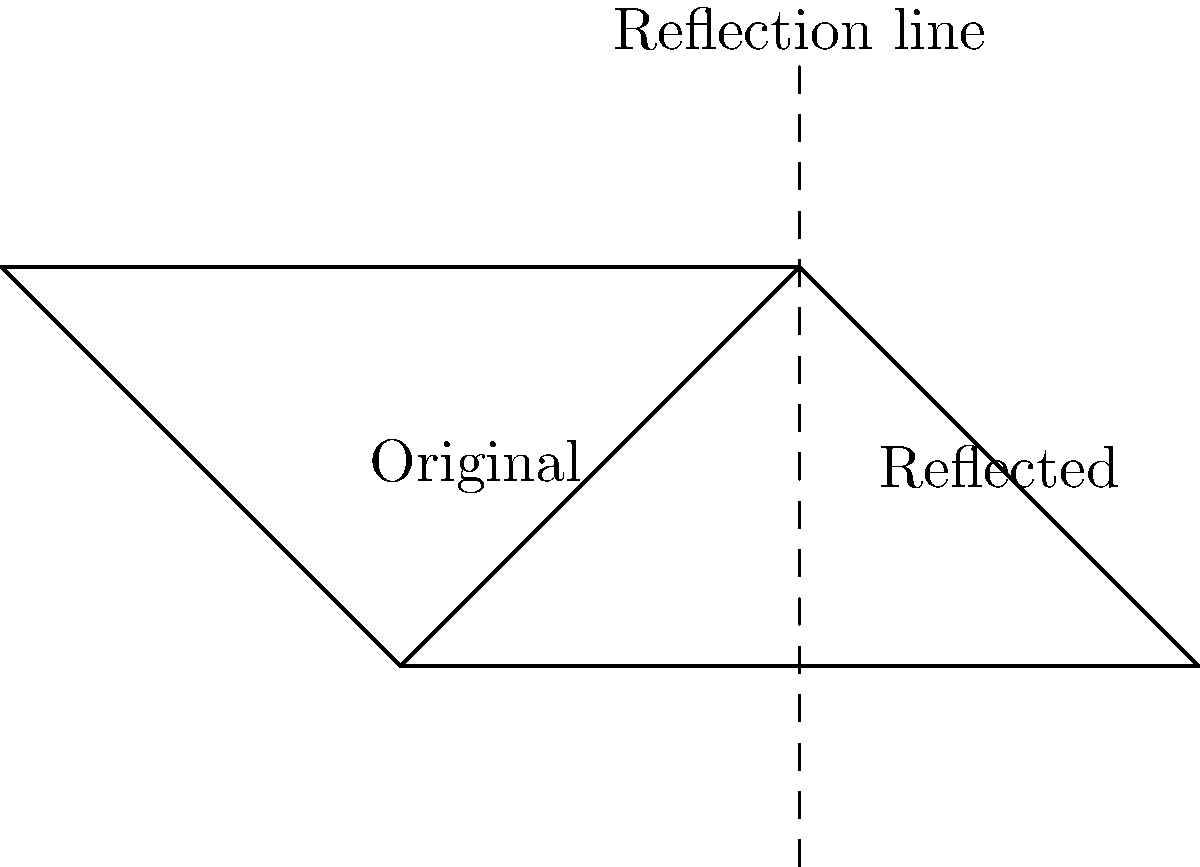In the diagram, a cross symbol is reflected across a vertical line. If the coordinates of the original cross's vertices are A(0,0), B(1,1), and C(2,0), what are the coordinates of the corresponding vertices in the reflected cross? To find the coordinates of the reflected cross, we need to apply the principle of reflection across a vertical line. The reflection line is at x = 1.

Step 1: Identify the distance of each point from the reflection line.
- A is 1 unit to the left of the line
- B is on the line
- C is 1 unit to the right of the line

Step 2: Reflect each point across the line.
- A will be 1 unit to the right of the line: (2,0)
- B will remain on the line: (1,1)
- C will be 1 unit to the left of the line: (0,0)

Step 3: Write the coordinates of the reflected vertices.
D(2,0), E(1,1), F(0,0)

The reflection preserves the y-coordinates and changes the x-coordinates symmetrically about x = 1.
Answer: D(2,0), E(1,1), F(0,0) 